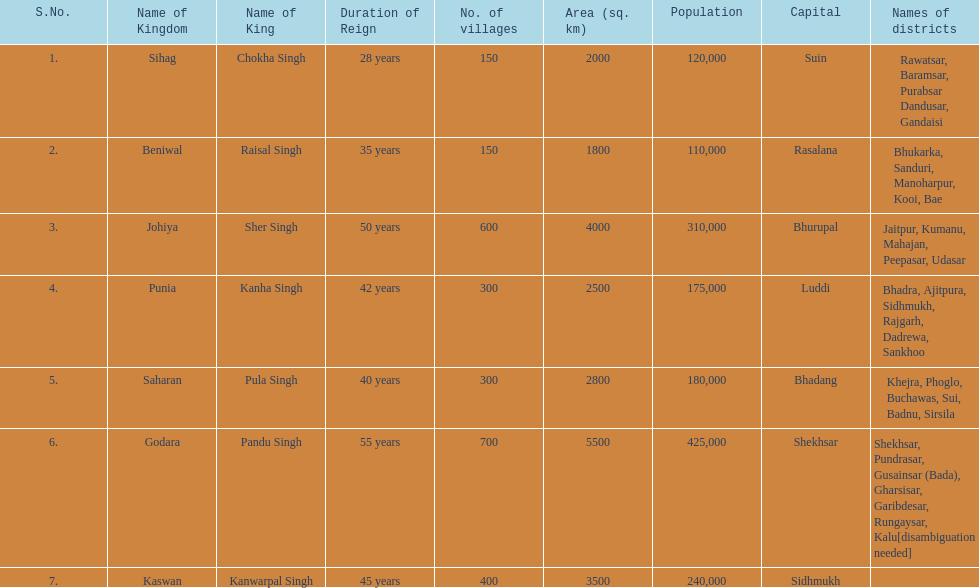Does punia have more or less villages than godara? Less. 